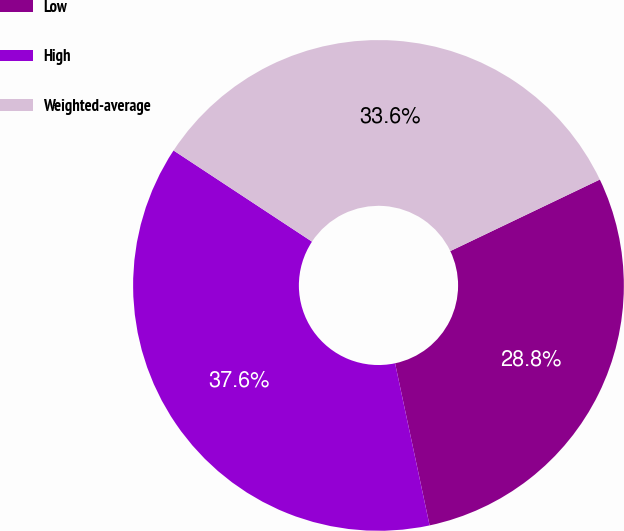Convert chart to OTSL. <chart><loc_0><loc_0><loc_500><loc_500><pie_chart><fcel>Low<fcel>High<fcel>Weighted-average<nl><fcel>28.76%<fcel>37.61%<fcel>33.63%<nl></chart> 